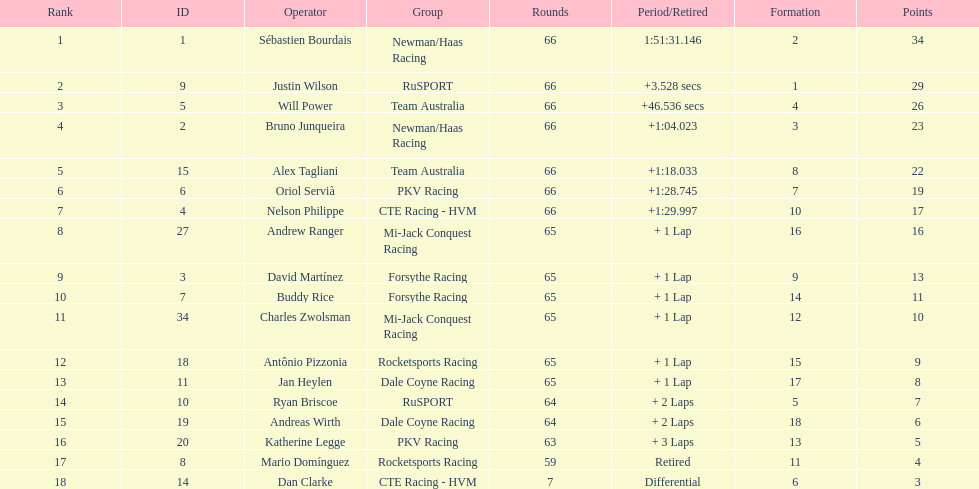Would you be able to parse every entry in this table? {'header': ['Rank', 'ID', 'Operator', 'Group', 'Rounds', 'Period/Retired', 'Formation', 'Points'], 'rows': [['1', '1', 'Sébastien Bourdais', 'Newman/Haas Racing', '66', '1:51:31.146', '2', '34'], ['2', '9', 'Justin Wilson', 'RuSPORT', '66', '+3.528 secs', '1', '29'], ['3', '5', 'Will Power', 'Team Australia', '66', '+46.536 secs', '4', '26'], ['4', '2', 'Bruno Junqueira', 'Newman/Haas Racing', '66', '+1:04.023', '3', '23'], ['5', '15', 'Alex Tagliani', 'Team Australia', '66', '+1:18.033', '8', '22'], ['6', '6', 'Oriol Servià', 'PKV Racing', '66', '+1:28.745', '7', '19'], ['7', '4', 'Nelson Philippe', 'CTE Racing - HVM', '66', '+1:29.997', '10', '17'], ['8', '27', 'Andrew Ranger', 'Mi-Jack Conquest Racing', '65', '+ 1 Lap', '16', '16'], ['9', '3', 'David Martínez', 'Forsythe Racing', '65', '+ 1 Lap', '9', '13'], ['10', '7', 'Buddy Rice', 'Forsythe Racing', '65', '+ 1 Lap', '14', '11'], ['11', '34', 'Charles Zwolsman', 'Mi-Jack Conquest Racing', '65', '+ 1 Lap', '12', '10'], ['12', '18', 'Antônio Pizzonia', 'Rocketsports Racing', '65', '+ 1 Lap', '15', '9'], ['13', '11', 'Jan Heylen', 'Dale Coyne Racing', '65', '+ 1 Lap', '17', '8'], ['14', '10', 'Ryan Briscoe', 'RuSPORT', '64', '+ 2 Laps', '5', '7'], ['15', '19', 'Andreas Wirth', 'Dale Coyne Racing', '64', '+ 2 Laps', '18', '6'], ['16', '20', 'Katherine Legge', 'PKV Racing', '63', '+ 3 Laps', '13', '5'], ['17', '8', 'Mario Domínguez', 'Rocketsports Racing', '59', 'Retired', '11', '4'], ['18', '14', 'Dan Clarke', 'CTE Racing - HVM', '7', 'Differential', '6', '3']]} How many drivers did not make more than 60 laps? 2. 